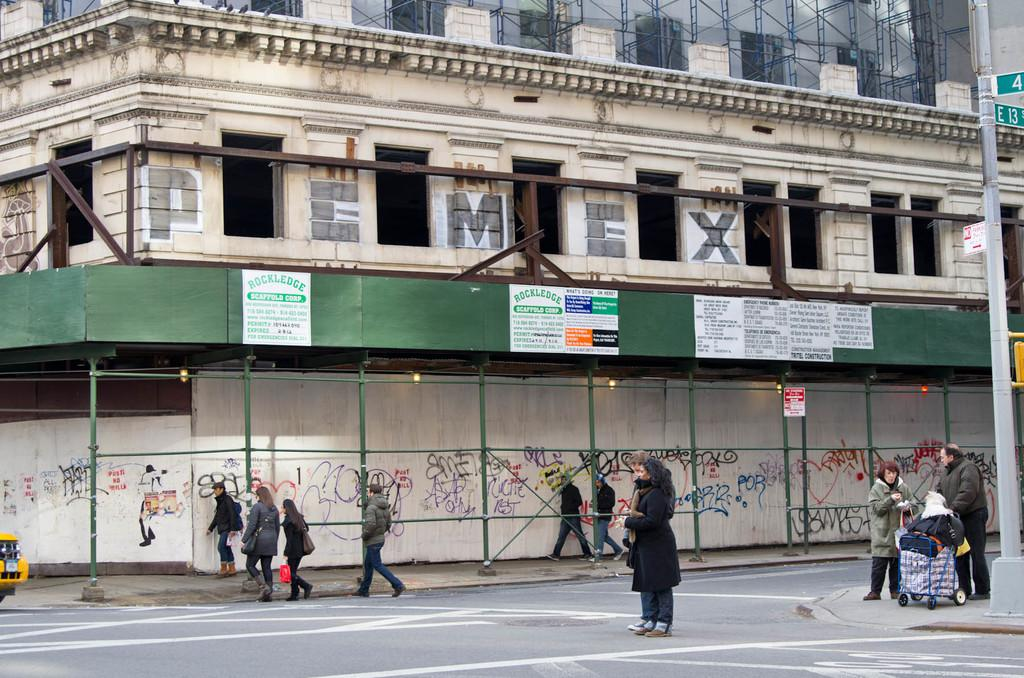<image>
Offer a succinct explanation of the picture presented. The name Pemex is painted on the side of a building. 